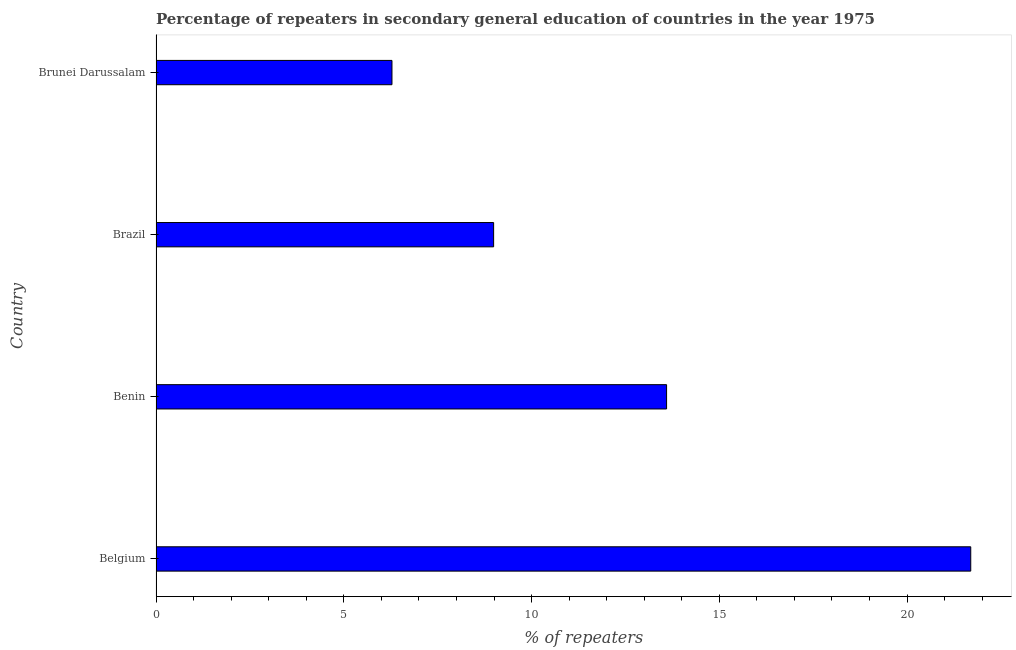Does the graph contain any zero values?
Your answer should be compact. No. What is the title of the graph?
Offer a very short reply. Percentage of repeaters in secondary general education of countries in the year 1975. What is the label or title of the X-axis?
Provide a short and direct response. % of repeaters. What is the percentage of repeaters in Benin?
Your answer should be very brief. 13.6. Across all countries, what is the maximum percentage of repeaters?
Ensure brevity in your answer.  21.7. Across all countries, what is the minimum percentage of repeaters?
Provide a short and direct response. 6.28. In which country was the percentage of repeaters maximum?
Give a very brief answer. Belgium. In which country was the percentage of repeaters minimum?
Keep it short and to the point. Brunei Darussalam. What is the sum of the percentage of repeaters?
Ensure brevity in your answer.  50.57. What is the difference between the percentage of repeaters in Benin and Brunei Darussalam?
Your response must be concise. 7.31. What is the average percentage of repeaters per country?
Keep it short and to the point. 12.64. What is the median percentage of repeaters?
Offer a terse response. 11.29. What is the ratio of the percentage of repeaters in Belgium to that in Benin?
Ensure brevity in your answer.  1.6. Is the difference between the percentage of repeaters in Benin and Brunei Darussalam greater than the difference between any two countries?
Give a very brief answer. No. What is the difference between the highest and the second highest percentage of repeaters?
Make the answer very short. 8.1. What is the difference between the highest and the lowest percentage of repeaters?
Ensure brevity in your answer.  15.41. Are all the bars in the graph horizontal?
Ensure brevity in your answer.  Yes. What is the difference between two consecutive major ticks on the X-axis?
Your answer should be compact. 5. Are the values on the major ticks of X-axis written in scientific E-notation?
Provide a succinct answer. No. What is the % of repeaters in Belgium?
Provide a short and direct response. 21.7. What is the % of repeaters of Benin?
Offer a very short reply. 13.6. What is the % of repeaters in Brazil?
Make the answer very short. 8.99. What is the % of repeaters of Brunei Darussalam?
Provide a succinct answer. 6.28. What is the difference between the % of repeaters in Belgium and Benin?
Provide a succinct answer. 8.1. What is the difference between the % of repeaters in Belgium and Brazil?
Give a very brief answer. 12.71. What is the difference between the % of repeaters in Belgium and Brunei Darussalam?
Keep it short and to the point. 15.41. What is the difference between the % of repeaters in Benin and Brazil?
Offer a terse response. 4.61. What is the difference between the % of repeaters in Benin and Brunei Darussalam?
Provide a short and direct response. 7.31. What is the difference between the % of repeaters in Brazil and Brunei Darussalam?
Ensure brevity in your answer.  2.71. What is the ratio of the % of repeaters in Belgium to that in Benin?
Make the answer very short. 1.6. What is the ratio of the % of repeaters in Belgium to that in Brazil?
Your answer should be compact. 2.41. What is the ratio of the % of repeaters in Belgium to that in Brunei Darussalam?
Ensure brevity in your answer.  3.45. What is the ratio of the % of repeaters in Benin to that in Brazil?
Your answer should be compact. 1.51. What is the ratio of the % of repeaters in Benin to that in Brunei Darussalam?
Offer a terse response. 2.16. What is the ratio of the % of repeaters in Brazil to that in Brunei Darussalam?
Make the answer very short. 1.43. 